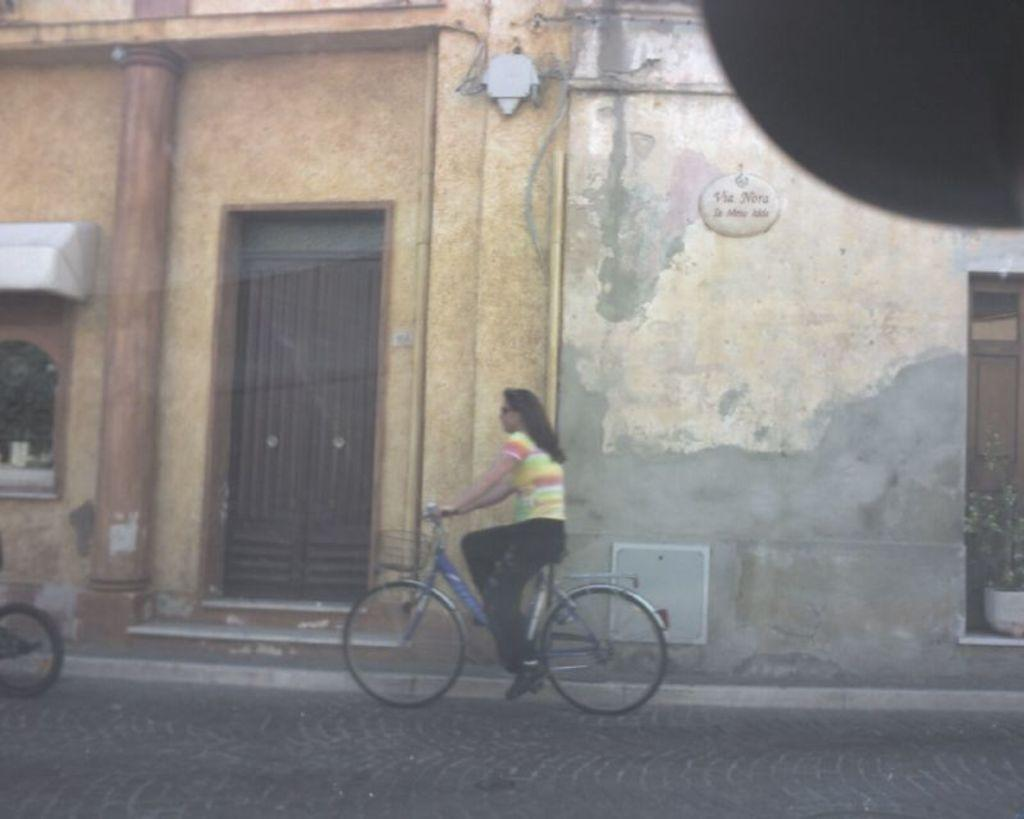Who is the main subject in the image? There is a woman in the image. What is the woman doing in the image? The woman is riding a bicycle. What can be seen in the background of the image? There is a building in the background of the image. What type of vegetation is on the right side of the image? There is a plant on the right side of the image. Can you hear the woman whistling while riding the bicycle in the image? There is no indication of any sound, such as whistling, in the image. 